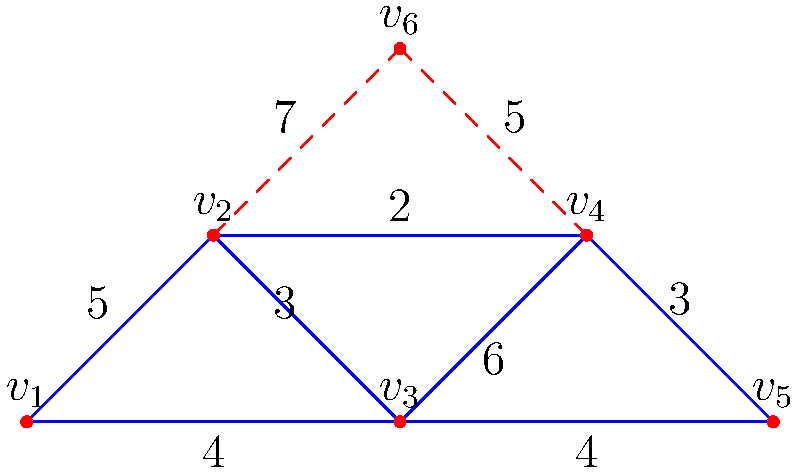The graph represents a structural support system for a ship, where vertices are connection points and edges are support beams. The weights on the edges represent the cost (in millions) to install each beam. What is the minimum total cost to connect all points using a spanning tree, and how many beams from the original design need to be removed to achieve this? To solve this problem, we need to find the Minimum Spanning Tree (MST) of the given graph. We can use Kruskal's algorithm to find the MST:

1. Sort all edges by weight in ascending order:
   (v2, v4): 2
   (v1, v2): 3
   (v3, v4): 3
   (v0, v2): 4
   (v2, v4): 4
   (v0, v1): 5
   (v2, v3): 6
   (v1, v5): 7
   (v3, v5): 5

2. Start with an empty set and add edges in order, skipping those that would create a cycle:
   - Add (v2, v4): 2
   - Add (v1, v2): 3
   - Add (v3, v4): 3
   - Add (v0, v2): 4
   - Skip (v2, v4): 4 (would create a cycle)
   - Add (v0, v1): 5

3. The MST is now complete with 5 edges (n-1 edges for n vertices).

4. Calculate the total cost of the MST:
   2 + 3 + 3 + 4 + 5 = 17 million

5. Count removed edges:
   Original graph had 9 edges, MST has 5 edges.
   Removed edges = 9 - 5 = 4

Therefore, the minimum total cost is $17 million, and 4 beams need to be removed from the original design.
Answer: $17 million; 4 beams 